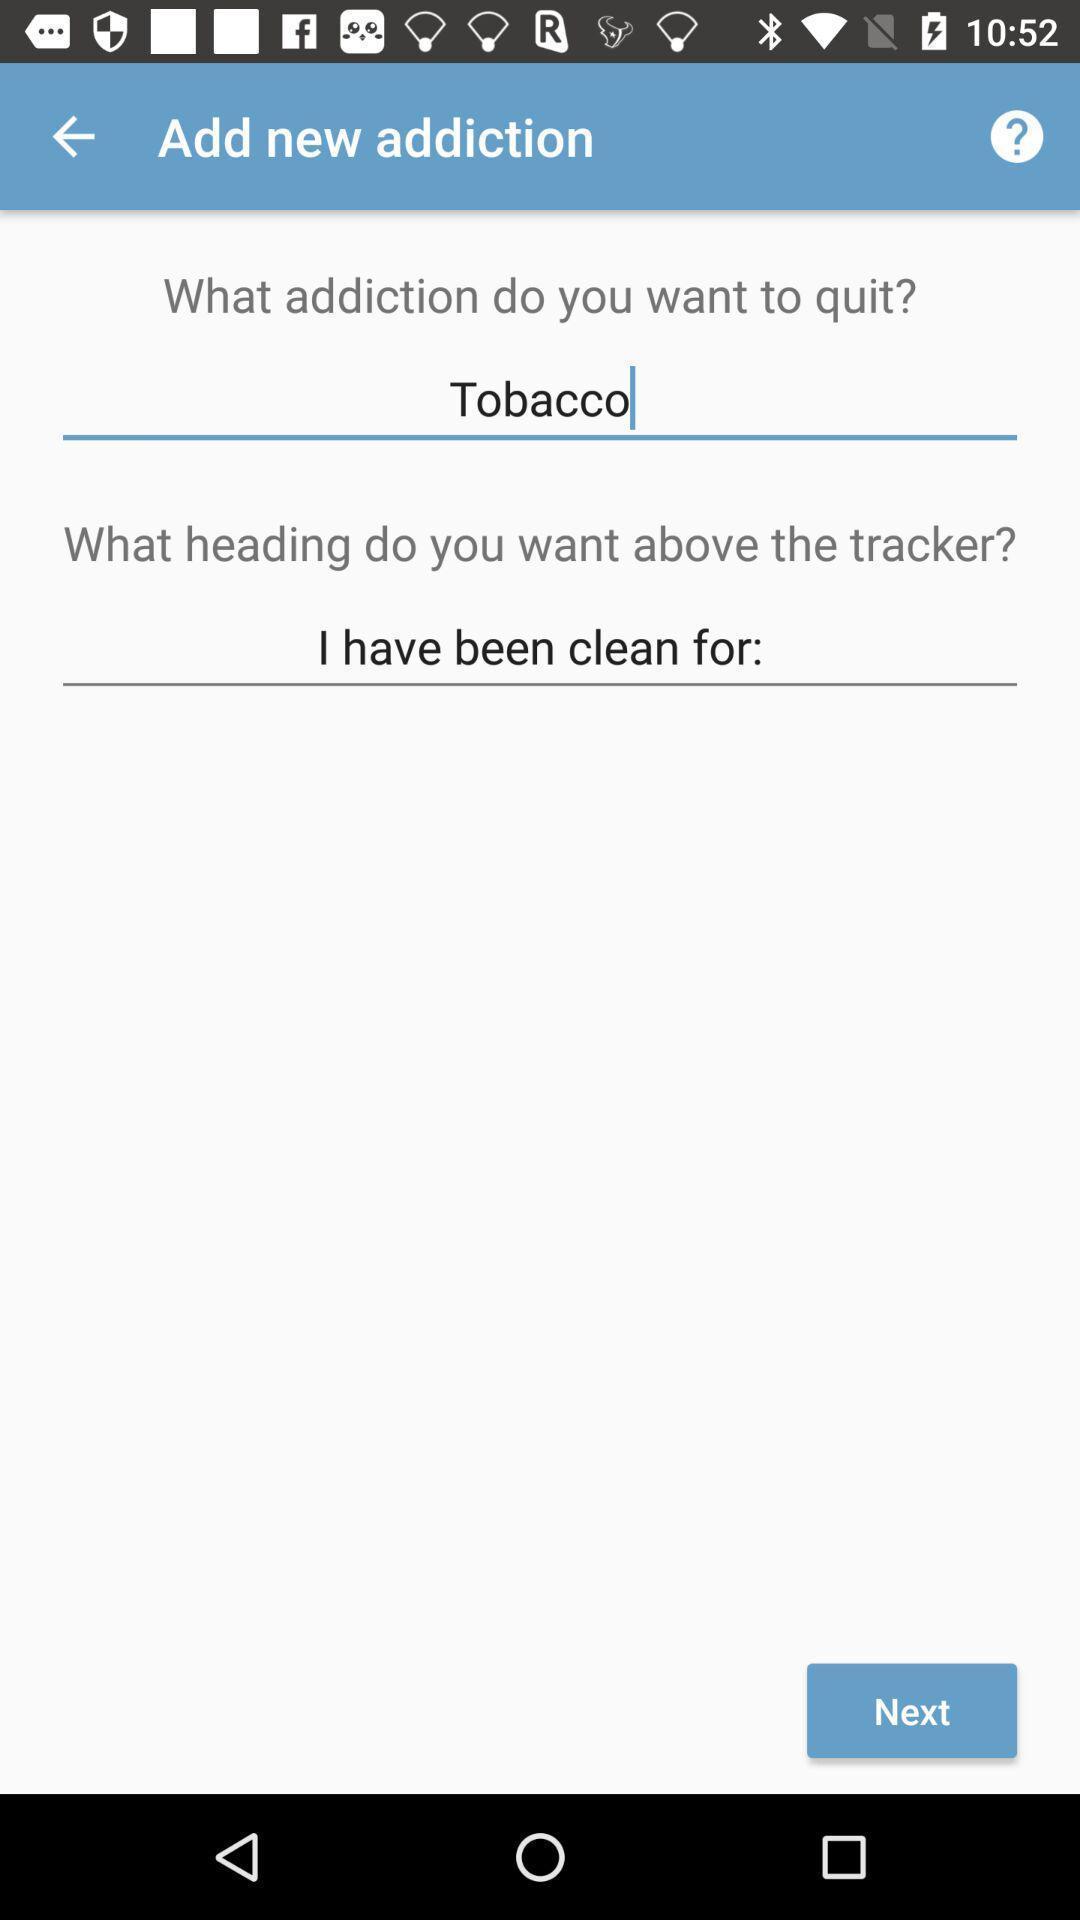Describe the content in this image. Screen showing add new addiction option. 